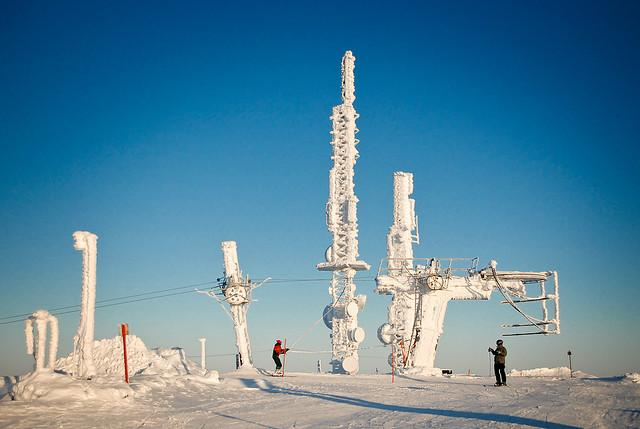Why is the machinery white?

Choices:
A) toilet paper
B) snow covered
C) styrofoam
D) painted white snow covered 